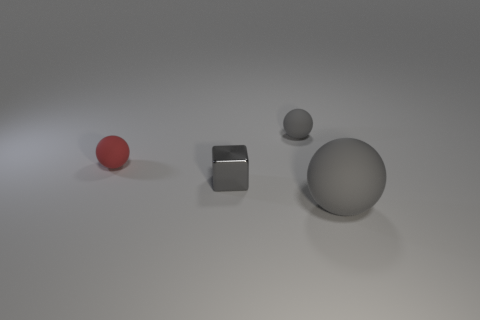Subtract all big gray rubber spheres. How many spheres are left? 2 Subtract all red spheres. How many spheres are left? 2 Add 2 big blue metal balls. How many objects exist? 6 Subtract all balls. How many objects are left? 1 Subtract all gray cubes. How many red spheres are left? 1 Add 1 small gray things. How many small gray things are left? 3 Add 3 small cyan cylinders. How many small cyan cylinders exist? 3 Subtract 0 brown cubes. How many objects are left? 4 Subtract 2 balls. How many balls are left? 1 Subtract all cyan balls. Subtract all blue blocks. How many balls are left? 3 